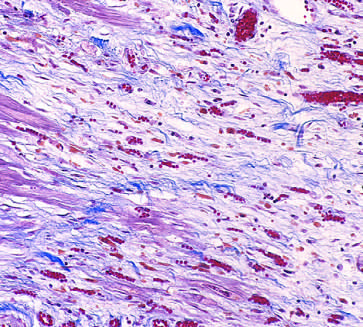what is granulation tissue characterized by?
Answer the question using a single word or phrase. Loose connective and abundant capillaries 